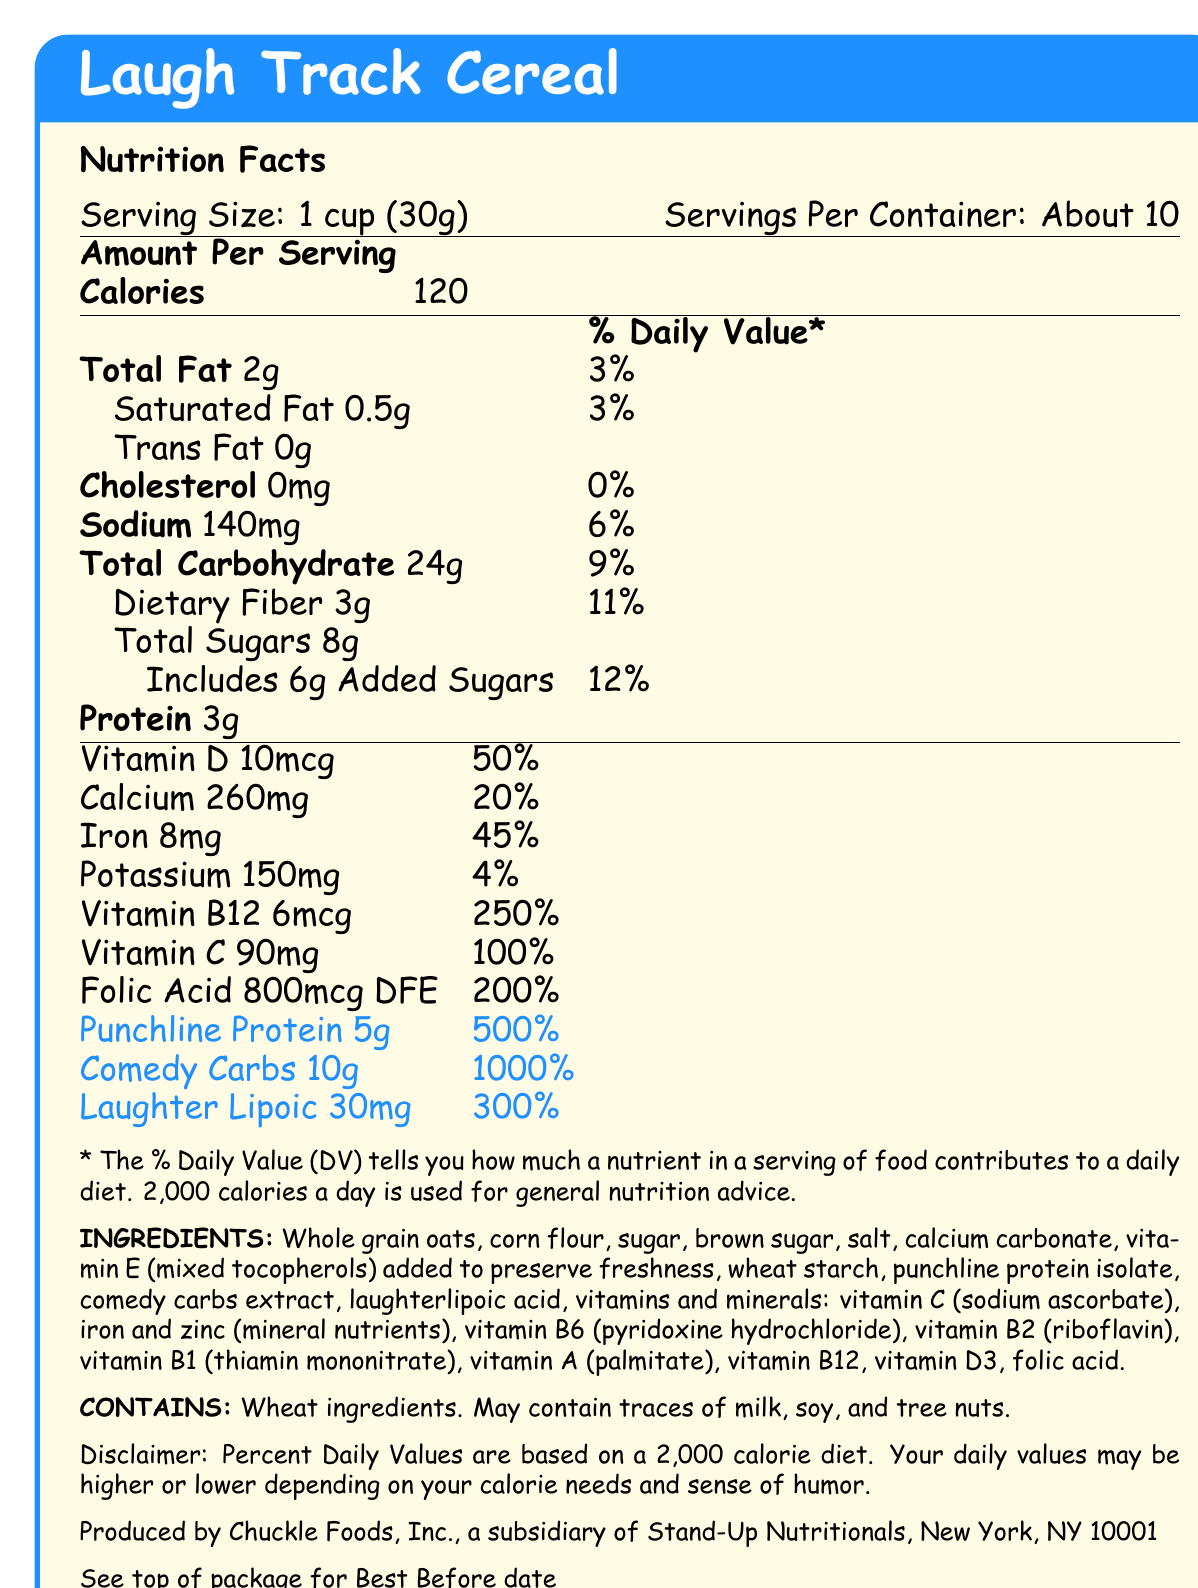What is the serving size of Laugh Track Cereal? The serving size is clearly stated as 1 cup (30g) in the document.
Answer: 1 cup (30g) How many calories are in one serving of Laugh Track Cereal? The calories per serving are listed as 120.
Answer: 120 What is the percentage of daily value for Vitamin B12 in Laugh Track Cereal? The document specifies that Vitamin B12 has a 250% daily value per serving.
Answer: 250% Does Laugh Track Cereal contain any trans fat? The document lists trans fat as 0g.
Answer: No List three ingredients found in Laugh Track Cereal. These ingredients are listed in the ingredients section of the document.
Answer: Whole grain oats, corn flour, sugar What is the % daily value of Punchline Protein in Laugh Track Cereal? Punchline Protein is listed with a 500% daily value in the document.
Answer: 500% Which of the following nutrients has the highest % daily value per serving in Laugh Track Cereal?
A. Vitamin C
B. Iron
C. Comedy Carbs Comedy Carbs have a 1000% daily value, which is higher than the other options provided.
Answer: C How much dietary fiber is in a serving of Laugh Track Cereal?
A. 1g
B. 2g
C. 3g The document lists dietary fiber as 3g per serving.
Answer: C Does Laugh Track Cereal contain any allergens? The document mentions that it contains wheat ingredients and may contain traces of milk, soy, and tree nuts.
Answer: Yes Summarize the main idea of the Nutrition Facts Label for Laugh Track Cereal. The document presents a comprehensive overview of the nutritional content and ingredients of Laugh Track Cereal, highlighting its unique and humorously exaggerated nutritional values.
Answer: Laugh Track Cereal provides detailed nutritional information including serving size, calories, and percent daily values for various nutrients. It emphasizes high levels of comedic nutrients like Punchline Protein, Comedy Carbs, and Laughter Lipoic, which have extraordinarily high daily values. The ingredients list includes both common cereal ingredients and comical additions. What is the specific purpose of the added vitamin E in the ingredients list? The document specifies that vitamin E is added to preserve freshness, but it does not detail its specific purpose beyond that general statement.
Answer: Not enough information 